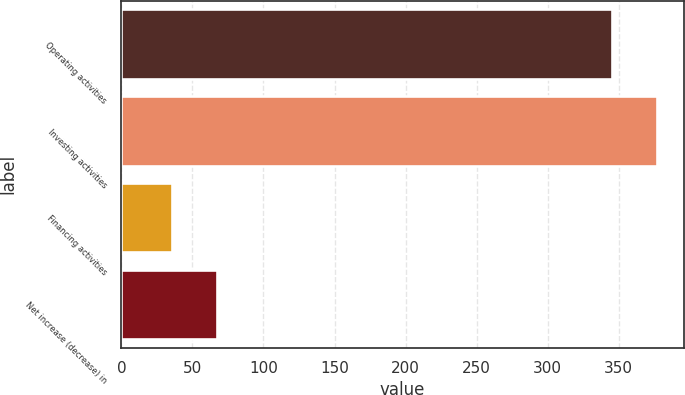Convert chart. <chart><loc_0><loc_0><loc_500><loc_500><bar_chart><fcel>Operating activities<fcel>Investing activities<fcel>Financing activities<fcel>Net increase (decrease) in<nl><fcel>345.5<fcel>376.95<fcel>35.6<fcel>67.05<nl></chart> 